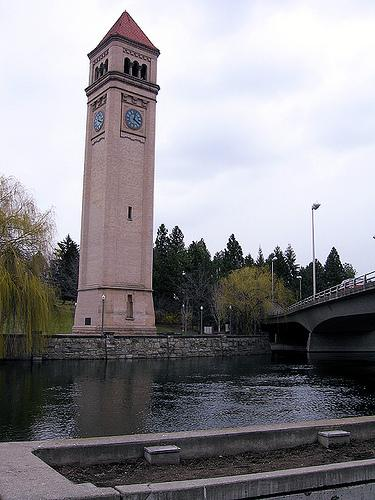What is the clock attached to? Please explain your reasoning. tower. The clock is outside and is high above the ground. 